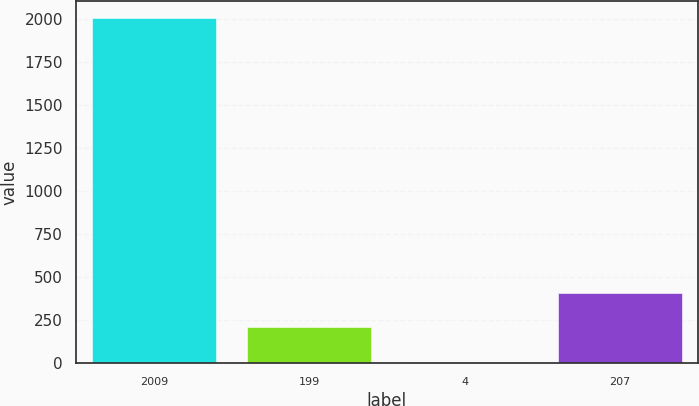<chart> <loc_0><loc_0><loc_500><loc_500><bar_chart><fcel>2009<fcel>199<fcel>4<fcel>207<nl><fcel>2008<fcel>208.9<fcel>9<fcel>408.8<nl></chart> 